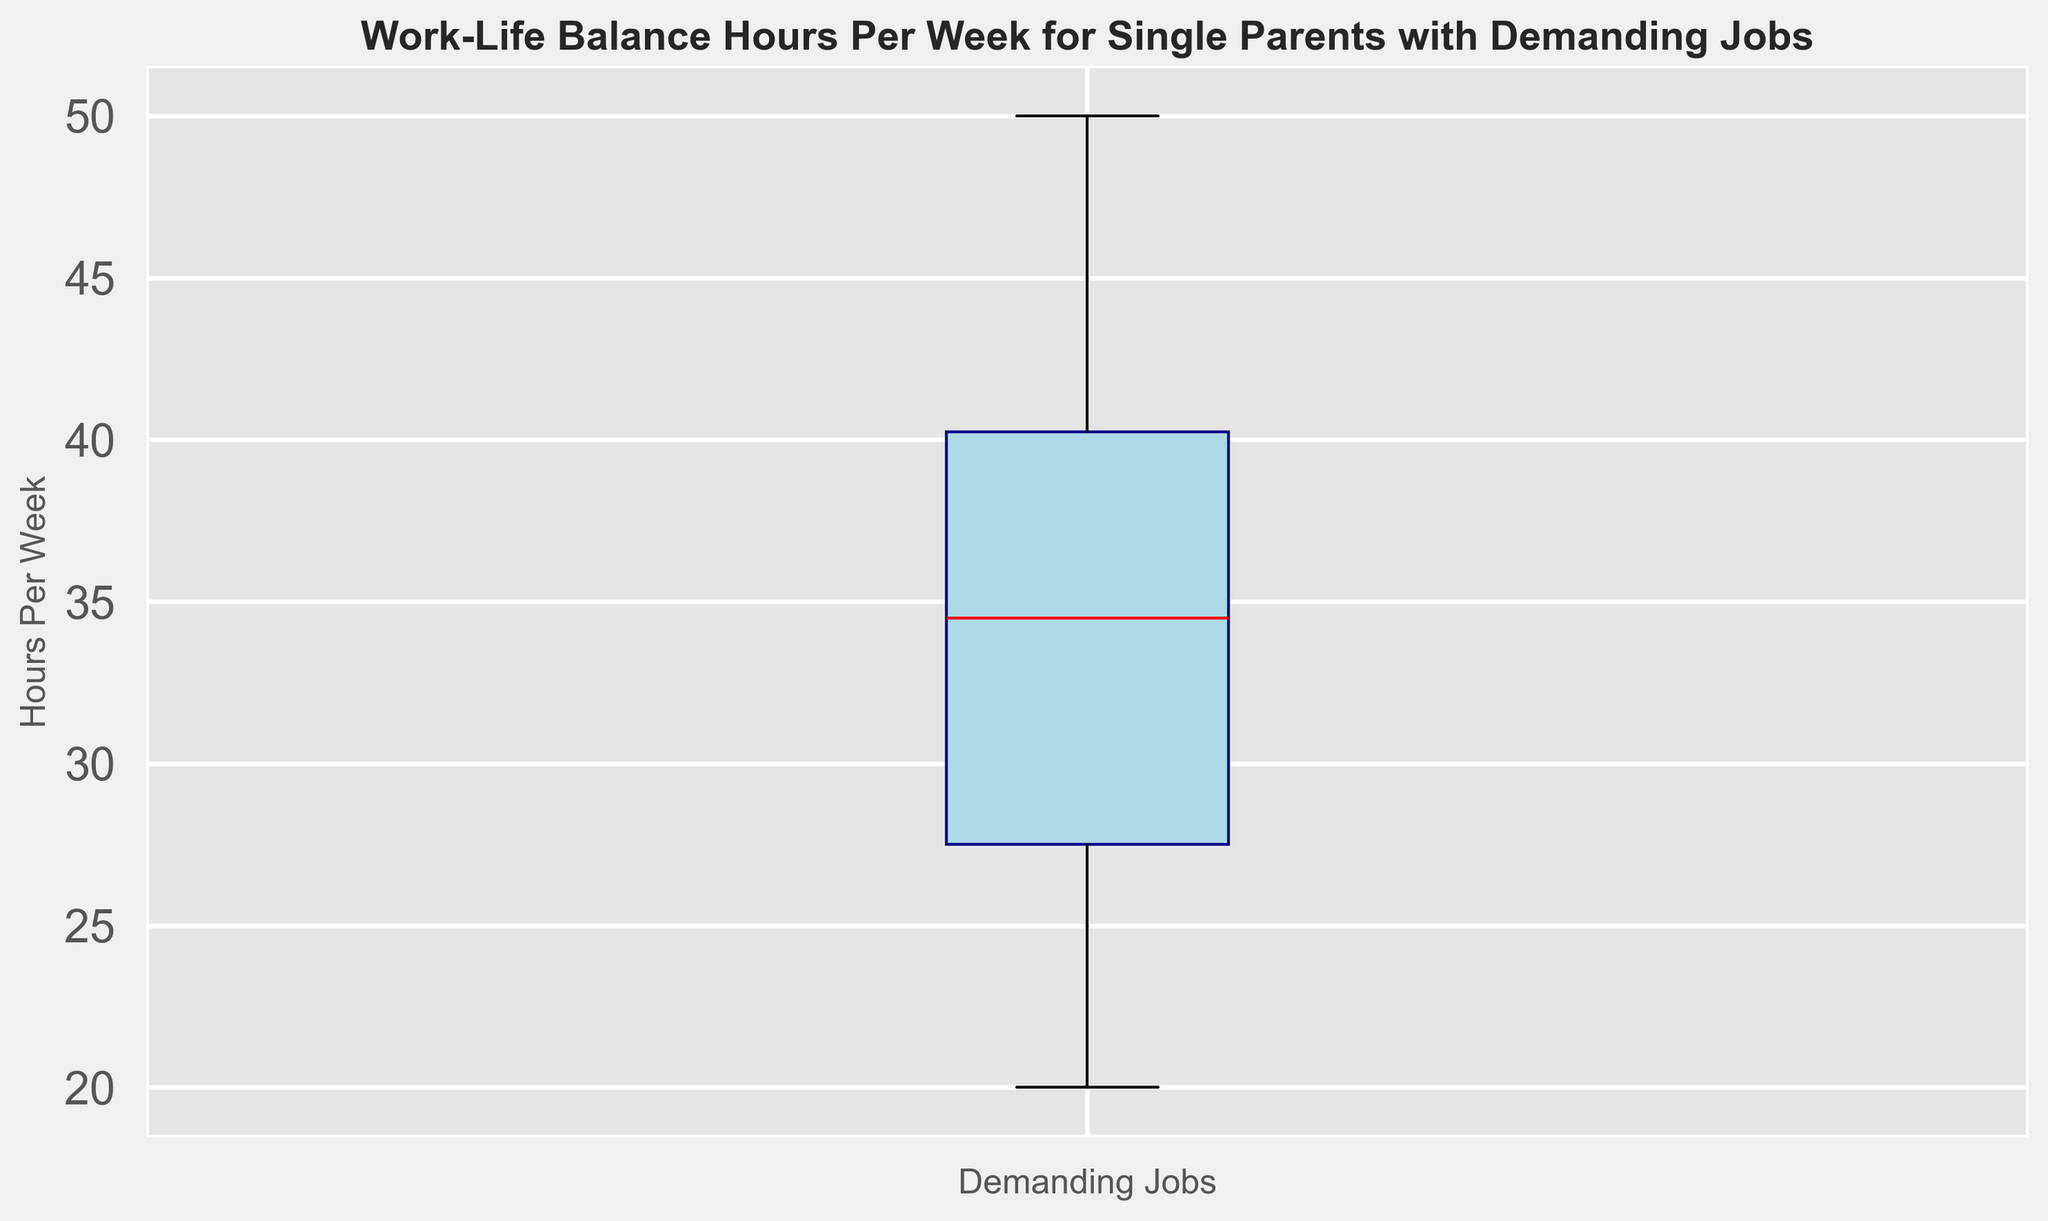What's the median value of Work-Life Balance Hours Per Week? The median is the middle value in the dataset when the values are arranged in order. By looking at the box plot, the red line inside the box represents the median. Typically, you refer to the y-axis value at this line.
Answer: 35 hours per week What is the range of Work-Life Balance Hours Per Week? The range is calculated by subtracting the smallest value from the largest value. In the box plot, the whiskers represent the minimum and maximum values. The maximum is 50, and the minimum is 20. Thus, the range is 50 - 20.
Answer: 30 hours per week Are there any outliers in the dataset? Outliers would be represented by points that lie outside the whiskers in a box plot. Since there are no individual points beyond the whiskers, there are no outliers.
Answer: No Which value has the highest frequency, the median or the mean? The box plot primarily shows the median, not the mean. However, typically in box plots, the median line (red) if referencing higher in the distribution means more points intersect it. The mean generally isn't depicted. So, we'd look to detailed dataset to declare frequency.
Answer: Median What does the width of the box indicate? The width of the box plot itself doesn't signify anything; it's the height that matters. The height of the box indicates the interquartile range (IQR), representing the middle 50% of the data. In this plot, it shows the distribution and spread of the Work-Life Balance Hours Per Week.
Answer: Interquartile range (IQR) How many hours per week is the third quartile (Q3)? The third quartile represents the median of the upper half of the dataset. In the box plot, it's the top edge of the box. You look for the y-axis value at this point.
Answer: 40 hours per week What is the interquartile range (IQR) of the data? The IQR is calculated as the difference between the third quartile (Q3) and the first quartile (Q1). From the box plot, Q3 is 40, and Q1 is 28. Therefore, IQR = 40 - 28.
Answer: 12 hours per week What percentage of the data lies within the interquartile range in a box plot? By definition, the IQR includes the middle 50% of the data. Therefore, you can conclude that 50% of the data lies within the IQR.
Answer: 50% Where is the mean likely to be in relation to the median in this box plot? In the box plot, the median is visible, but the mean isn't. However, if the plot appears symmetrical, the mean could be close to the median. For skewed data, it might differ. In this case, the plot seems reasonably symmetric.
Answer: Close to the median 